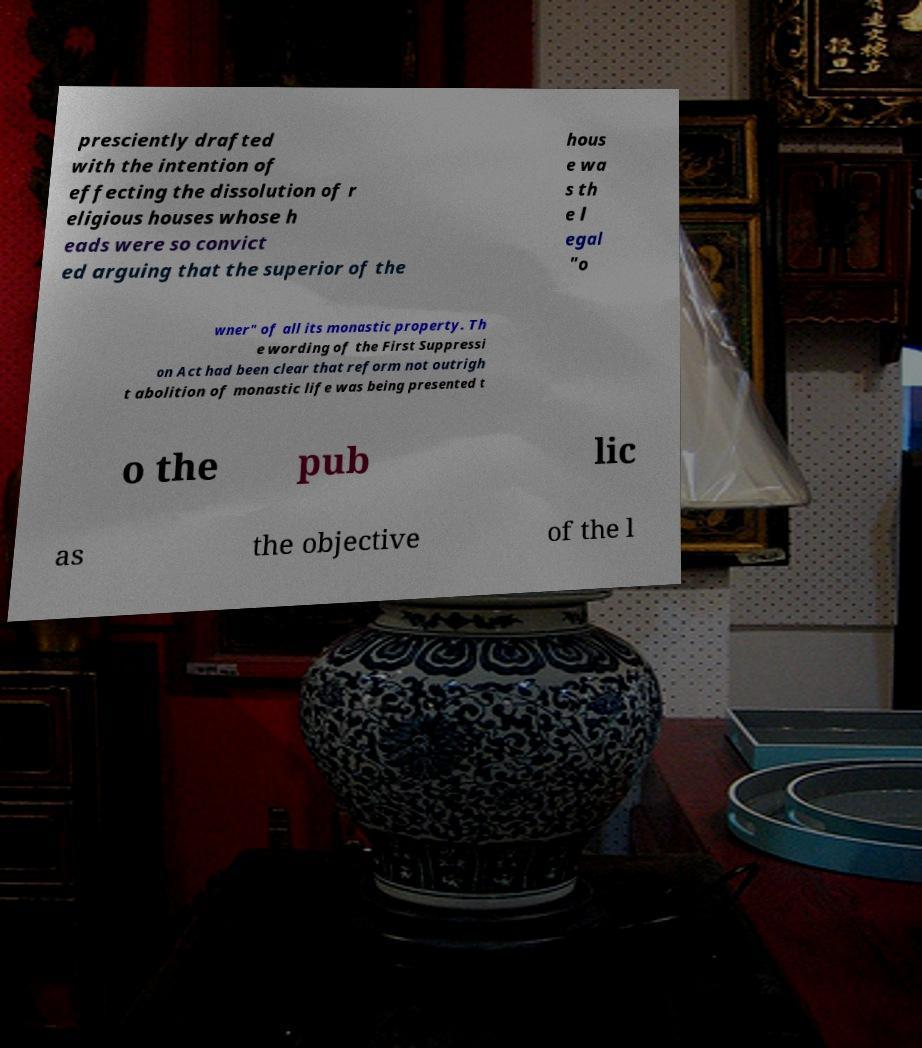I need the written content from this picture converted into text. Can you do that? presciently drafted with the intention of effecting the dissolution of r eligious houses whose h eads were so convict ed arguing that the superior of the hous e wa s th e l egal "o wner" of all its monastic property. Th e wording of the First Suppressi on Act had been clear that reform not outrigh t abolition of monastic life was being presented t o the pub lic as the objective of the l 